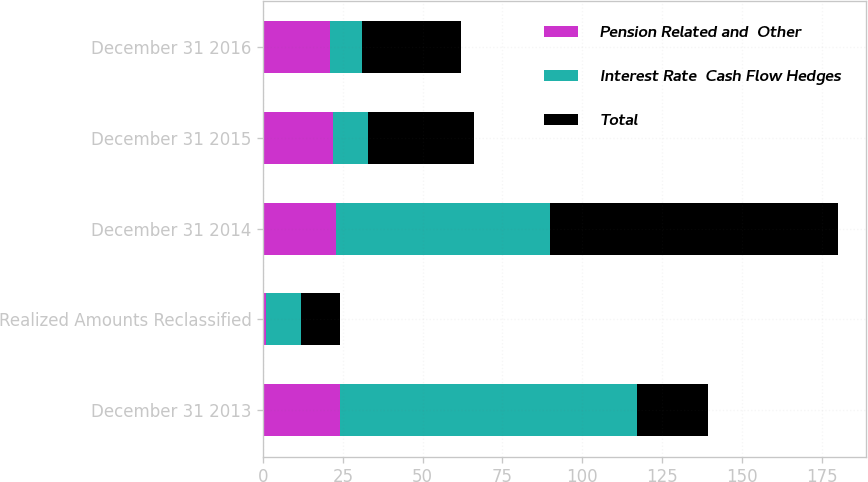Convert chart to OTSL. <chart><loc_0><loc_0><loc_500><loc_500><stacked_bar_chart><ecel><fcel>December 31 2013<fcel>Realized Amounts Reclassified<fcel>December 31 2014<fcel>December 31 2015<fcel>December 31 2016<nl><fcel>Pension Related and  Other<fcel>24<fcel>1<fcel>23<fcel>22<fcel>21<nl><fcel>Interest Rate  Cash Flow Hedges<fcel>93<fcel>11<fcel>67<fcel>11<fcel>10<nl><fcel>Total<fcel>22.5<fcel>12<fcel>90<fcel>33<fcel>31<nl></chart> 